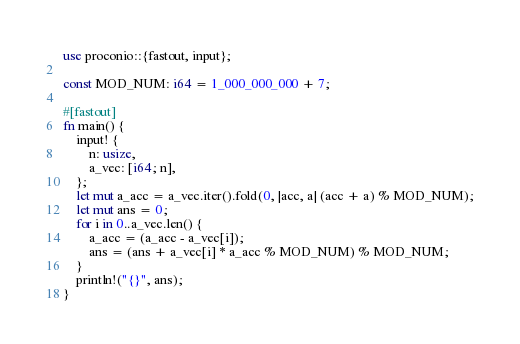Convert code to text. <code><loc_0><loc_0><loc_500><loc_500><_Rust_>use proconio::{fastout, input};

const MOD_NUM: i64 = 1_000_000_000 + 7;

#[fastout]
fn main() {
    input! {
        n: usize,
        a_vec: [i64; n],
    };
    let mut a_acc = a_vec.iter().fold(0, |acc, a| (acc + a) % MOD_NUM);
    let mut ans = 0;
    for i in 0..a_vec.len() {
        a_acc = (a_acc - a_vec[i]);
        ans = (ans + a_vec[i] * a_acc % MOD_NUM) % MOD_NUM;
    }
    println!("{}", ans);
}
</code> 